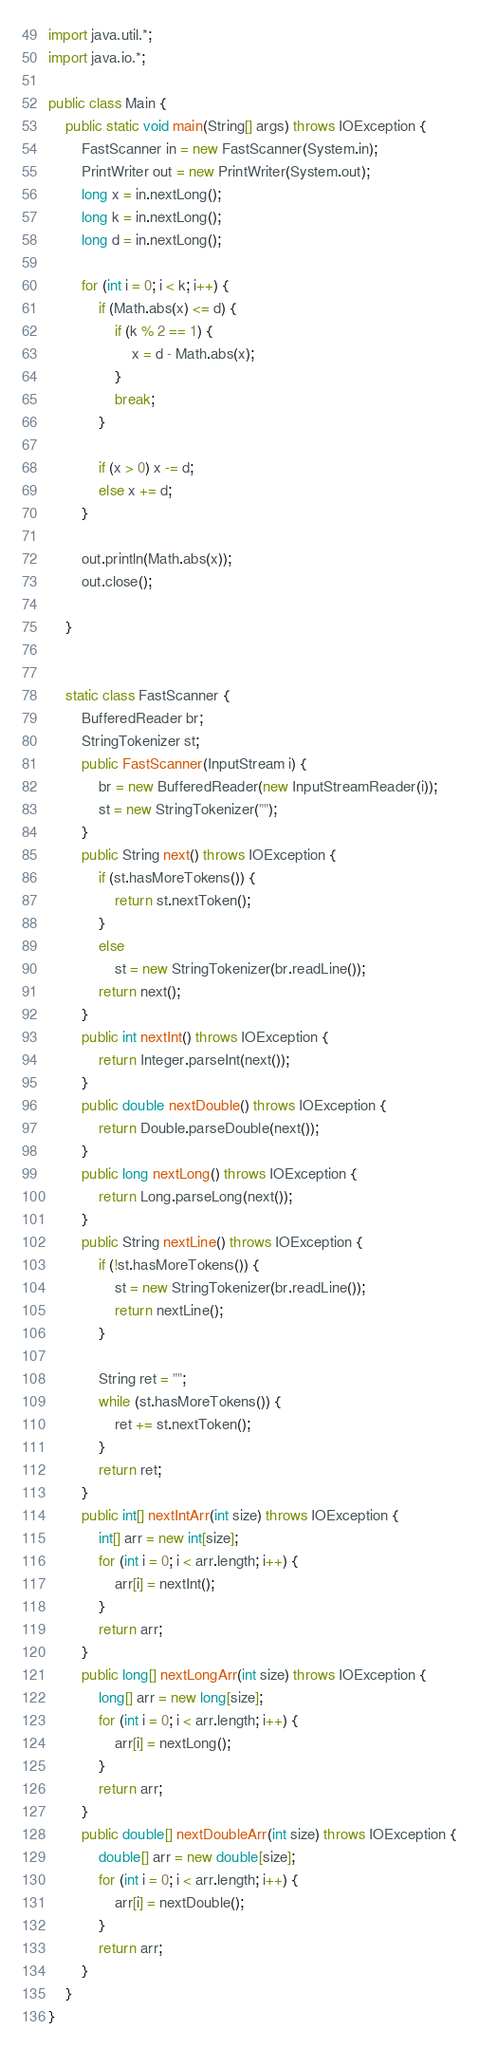<code> <loc_0><loc_0><loc_500><loc_500><_Java_>import java.util.*;
import java.io.*;

public class Main {
    public static void main(String[] args) throws IOException {
        FastScanner in = new FastScanner(System.in);
        PrintWriter out = new PrintWriter(System.out);
        long x = in.nextLong();
        long k = in.nextLong();
        long d = in.nextLong();

        for (int i = 0; i < k; i++) {
            if (Math.abs(x) <= d) {
                if (k % 2 == 1) {
                    x = d - Math.abs(x);
                }
                break;
            }

            if (x > 0) x -= d;
            else x += d;
        }

        out.println(Math.abs(x));
        out.close();

    }


    static class FastScanner {
        BufferedReader br;
        StringTokenizer st;
        public FastScanner(InputStream i) {
            br = new BufferedReader(new InputStreamReader(i));
            st = new StringTokenizer("");
        }
        public String next() throws IOException {
            if (st.hasMoreTokens()) {
                return st.nextToken();
            }
            else
                st = new StringTokenizer(br.readLine());
            return next();
        }
        public int nextInt() throws IOException {
            return Integer.parseInt(next());
        }
        public double nextDouble() throws IOException {
            return Double.parseDouble(next());
        }
        public long nextLong() throws IOException {
            return Long.parseLong(next());
        }
        public String nextLine() throws IOException {
            if (!st.hasMoreTokens()) {
                st = new StringTokenizer(br.readLine());
                return nextLine();
            }

            String ret = "";
            while (st.hasMoreTokens()) {
                ret += st.nextToken();
            }
            return ret;
        }
        public int[] nextIntArr(int size) throws IOException {
            int[] arr = new int[size];
            for (int i = 0; i < arr.length; i++) {
                arr[i] = nextInt();
            }
            return arr;
        }
        public long[] nextLongArr(int size) throws IOException {
            long[] arr = new long[size];
            for (int i = 0; i < arr.length; i++) {
                arr[i] = nextLong();
            }
            return arr;
        }
        public double[] nextDoubleArr(int size) throws IOException {
            double[] arr = new double[size];
            for (int i = 0; i < arr.length; i++) {
                arr[i] = nextDouble();
            }
            return arr;
        }
    }
}</code> 